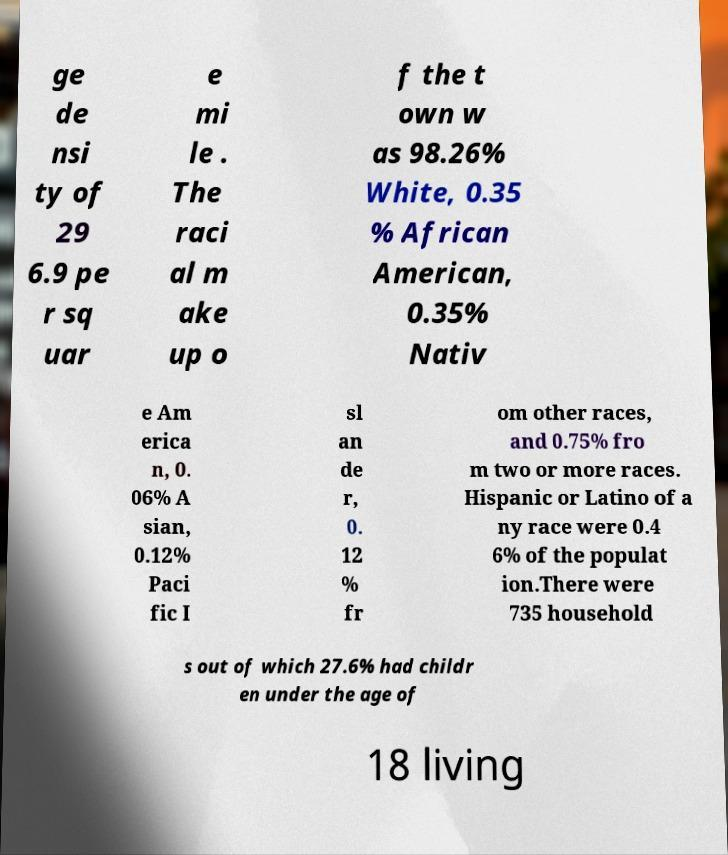Could you assist in decoding the text presented in this image and type it out clearly? ge de nsi ty of 29 6.9 pe r sq uar e mi le . The raci al m ake up o f the t own w as 98.26% White, 0.35 % African American, 0.35% Nativ e Am erica n, 0. 06% A sian, 0.12% Paci fic I sl an de r, 0. 12 % fr om other races, and 0.75% fro m two or more races. Hispanic or Latino of a ny race were 0.4 6% of the populat ion.There were 735 household s out of which 27.6% had childr en under the age of 18 living 